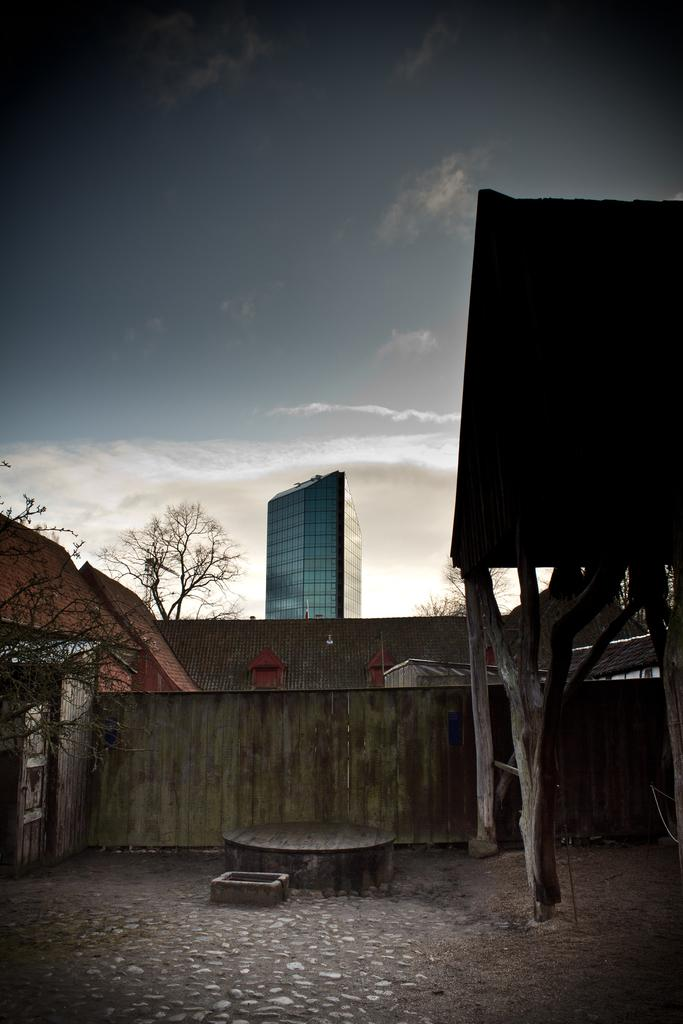What type of structures can be seen in the image? There are buildings in the image. What other natural elements are present in the image? There are trees in the image. What can be seen in the sky in the image? There are clouds in the image. What type of journey is depicted in the image? There is no journey depicted in the image; it features buildings, trees, and clouds. What type of recess can be seen in the image? There is no recess present in the image; it features buildings, trees, and clouds. 